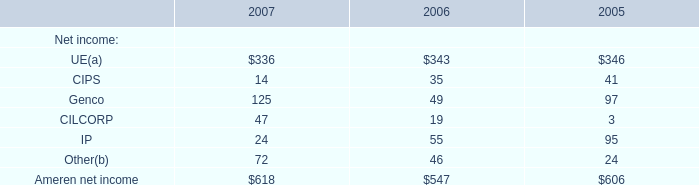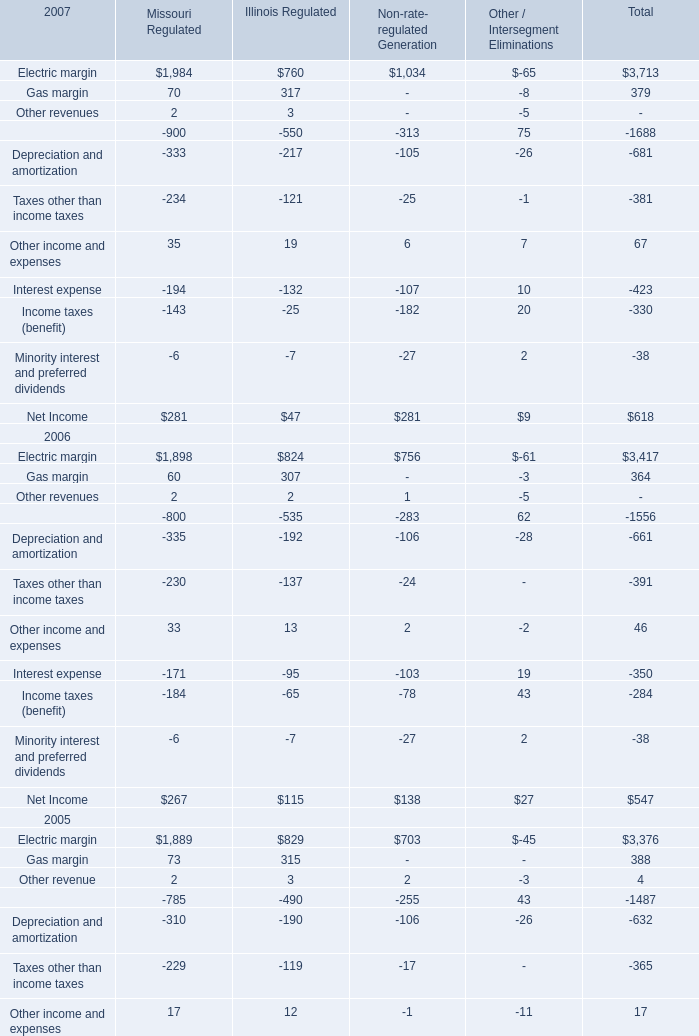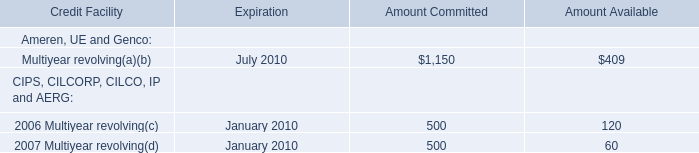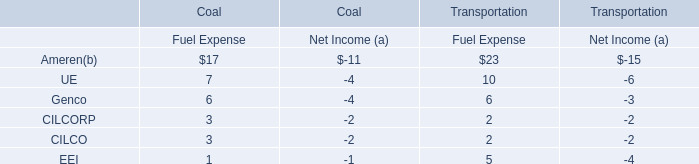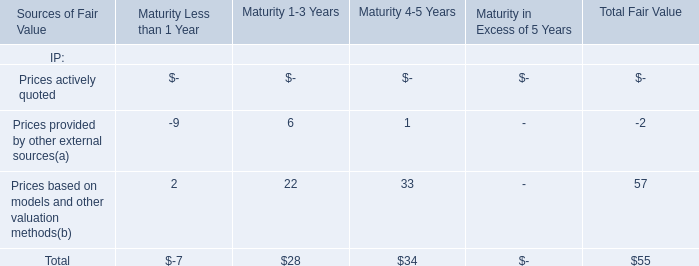What's the total amount of Electric margin, Gas margin, Other revenues and Other income and expenses in terms of Missouri Regulated in 2007? (in dollars) 
Computations: (((1984 + 70) + 2) + 35)
Answer: 2091.0. 